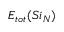Convert formula to latex. <formula><loc_0><loc_0><loc_500><loc_500>E _ { t o t } ( S i _ { N } )</formula> 